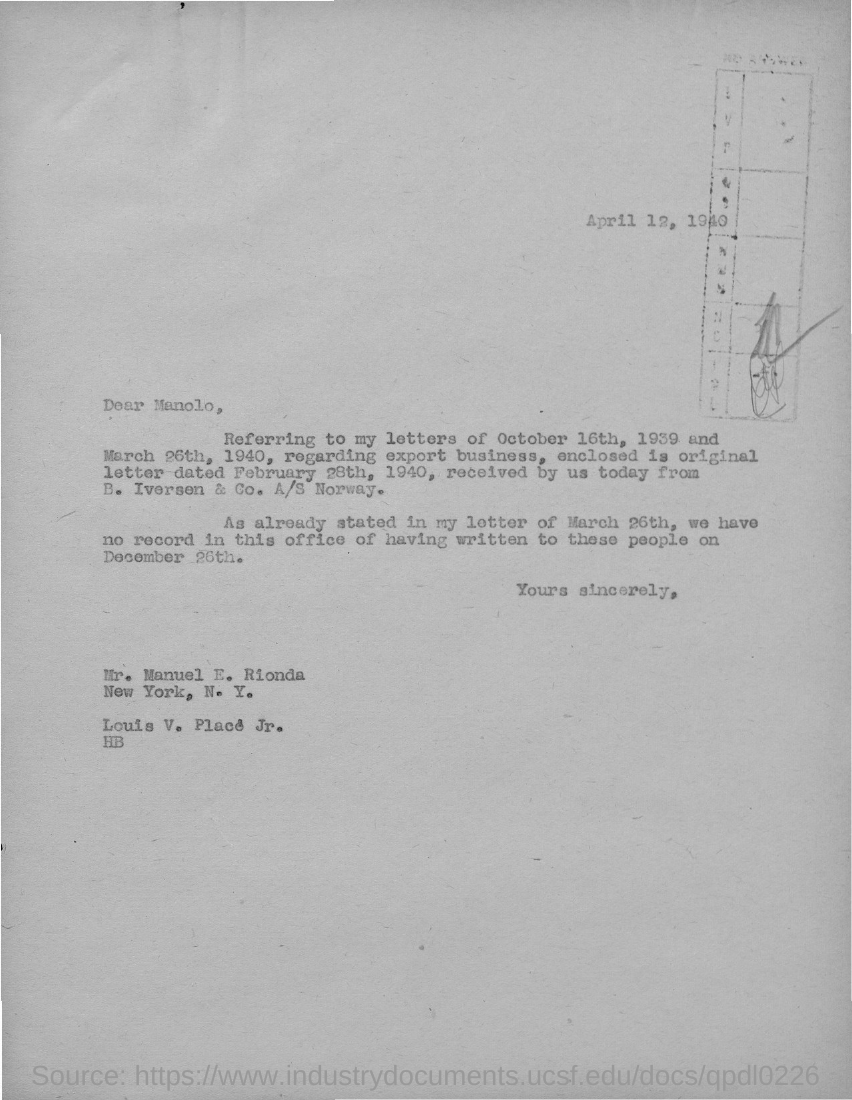What is the date mentioned in the given page ?
Your answer should be very brief. April 12, 1940. To whom the letter was sent ?
Provide a short and direct response. Mr. Manuel E. Rionda. 